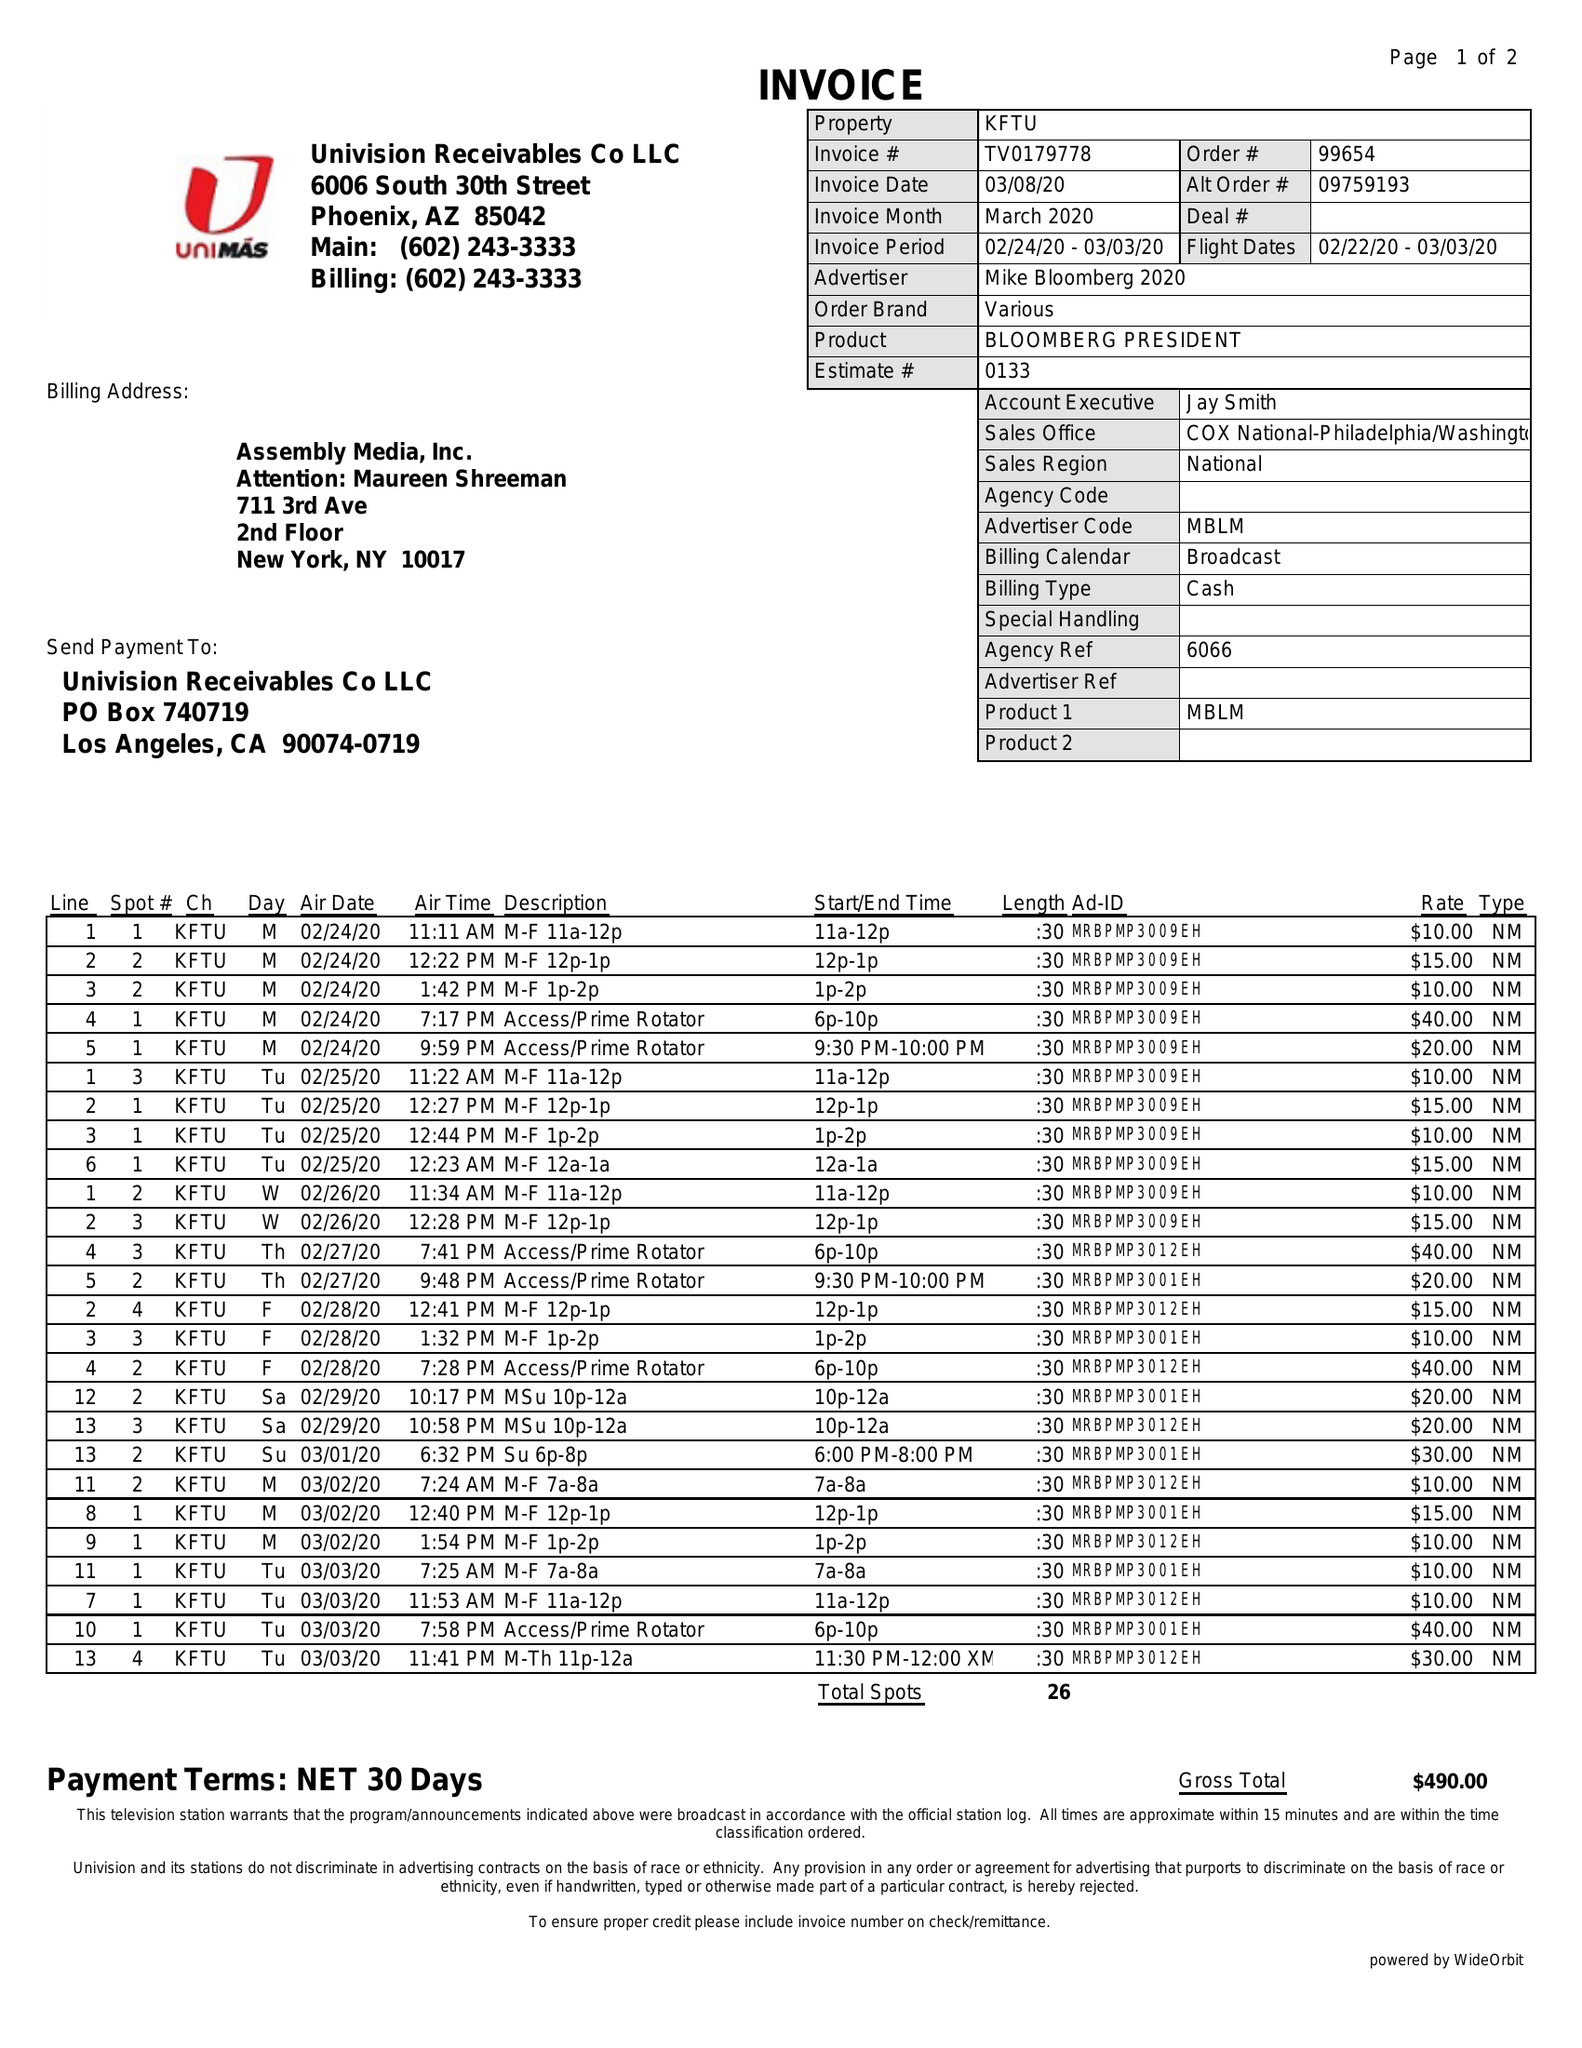What is the value for the flight_from?
Answer the question using a single word or phrase. 02/22/20 